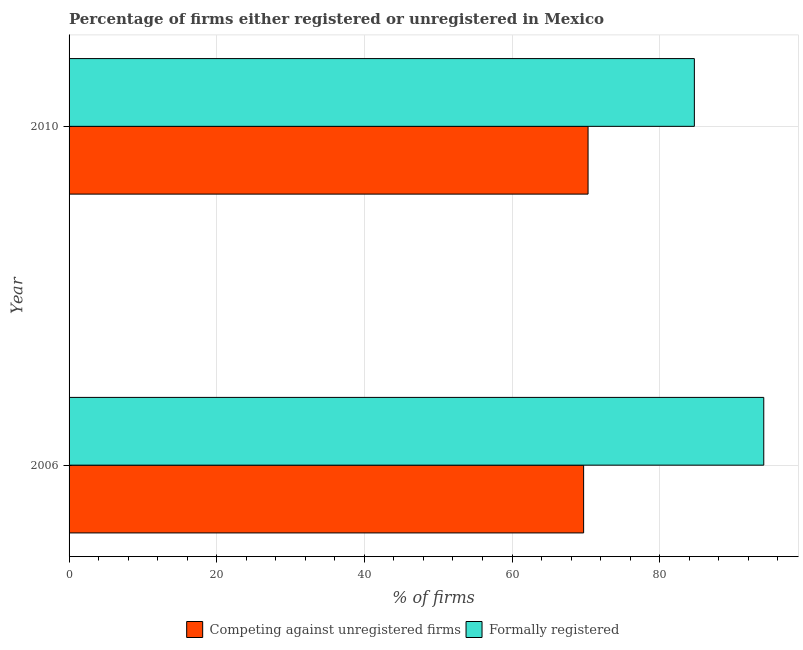How many groups of bars are there?
Your answer should be compact. 2. Are the number of bars on each tick of the Y-axis equal?
Provide a short and direct response. Yes. How many bars are there on the 2nd tick from the top?
Your response must be concise. 2. What is the label of the 1st group of bars from the top?
Your response must be concise. 2010. What is the percentage of formally registered firms in 2006?
Your response must be concise. 94.1. Across all years, what is the maximum percentage of registered firms?
Your answer should be very brief. 70.3. Across all years, what is the minimum percentage of formally registered firms?
Your response must be concise. 84.7. In which year was the percentage of formally registered firms maximum?
Offer a terse response. 2006. In which year was the percentage of registered firms minimum?
Keep it short and to the point. 2006. What is the total percentage of registered firms in the graph?
Keep it short and to the point. 140. What is the difference between the percentage of formally registered firms in 2010 and the percentage of registered firms in 2006?
Keep it short and to the point. 15. What is the average percentage of formally registered firms per year?
Your answer should be compact. 89.4. In the year 2006, what is the difference between the percentage of registered firms and percentage of formally registered firms?
Your answer should be compact. -24.4. Is the percentage of registered firms in 2006 less than that in 2010?
Ensure brevity in your answer.  Yes. In how many years, is the percentage of formally registered firms greater than the average percentage of formally registered firms taken over all years?
Offer a very short reply. 1. What does the 1st bar from the top in 2006 represents?
Your answer should be very brief. Formally registered. What does the 1st bar from the bottom in 2006 represents?
Your response must be concise. Competing against unregistered firms. Are the values on the major ticks of X-axis written in scientific E-notation?
Keep it short and to the point. No. Where does the legend appear in the graph?
Keep it short and to the point. Bottom center. How are the legend labels stacked?
Your answer should be very brief. Horizontal. What is the title of the graph?
Ensure brevity in your answer.  Percentage of firms either registered or unregistered in Mexico. Does "Canada" appear as one of the legend labels in the graph?
Keep it short and to the point. No. What is the label or title of the X-axis?
Provide a succinct answer. % of firms. What is the % of firms in Competing against unregistered firms in 2006?
Your answer should be very brief. 69.7. What is the % of firms in Formally registered in 2006?
Keep it short and to the point. 94.1. What is the % of firms in Competing against unregistered firms in 2010?
Provide a short and direct response. 70.3. What is the % of firms in Formally registered in 2010?
Offer a very short reply. 84.7. Across all years, what is the maximum % of firms in Competing against unregistered firms?
Your answer should be very brief. 70.3. Across all years, what is the maximum % of firms in Formally registered?
Give a very brief answer. 94.1. Across all years, what is the minimum % of firms of Competing against unregistered firms?
Your answer should be compact. 69.7. Across all years, what is the minimum % of firms of Formally registered?
Provide a succinct answer. 84.7. What is the total % of firms in Competing against unregistered firms in the graph?
Ensure brevity in your answer.  140. What is the total % of firms in Formally registered in the graph?
Ensure brevity in your answer.  178.8. What is the difference between the % of firms of Competing against unregistered firms in 2006 and that in 2010?
Your response must be concise. -0.6. What is the difference between the % of firms in Formally registered in 2006 and that in 2010?
Provide a short and direct response. 9.4. What is the difference between the % of firms of Competing against unregistered firms in 2006 and the % of firms of Formally registered in 2010?
Keep it short and to the point. -15. What is the average % of firms in Formally registered per year?
Keep it short and to the point. 89.4. In the year 2006, what is the difference between the % of firms in Competing against unregistered firms and % of firms in Formally registered?
Your answer should be very brief. -24.4. In the year 2010, what is the difference between the % of firms of Competing against unregistered firms and % of firms of Formally registered?
Your response must be concise. -14.4. What is the ratio of the % of firms of Formally registered in 2006 to that in 2010?
Provide a short and direct response. 1.11. What is the difference between the highest and the second highest % of firms in Competing against unregistered firms?
Provide a short and direct response. 0.6. What is the difference between the highest and the lowest % of firms of Competing against unregistered firms?
Provide a short and direct response. 0.6. 